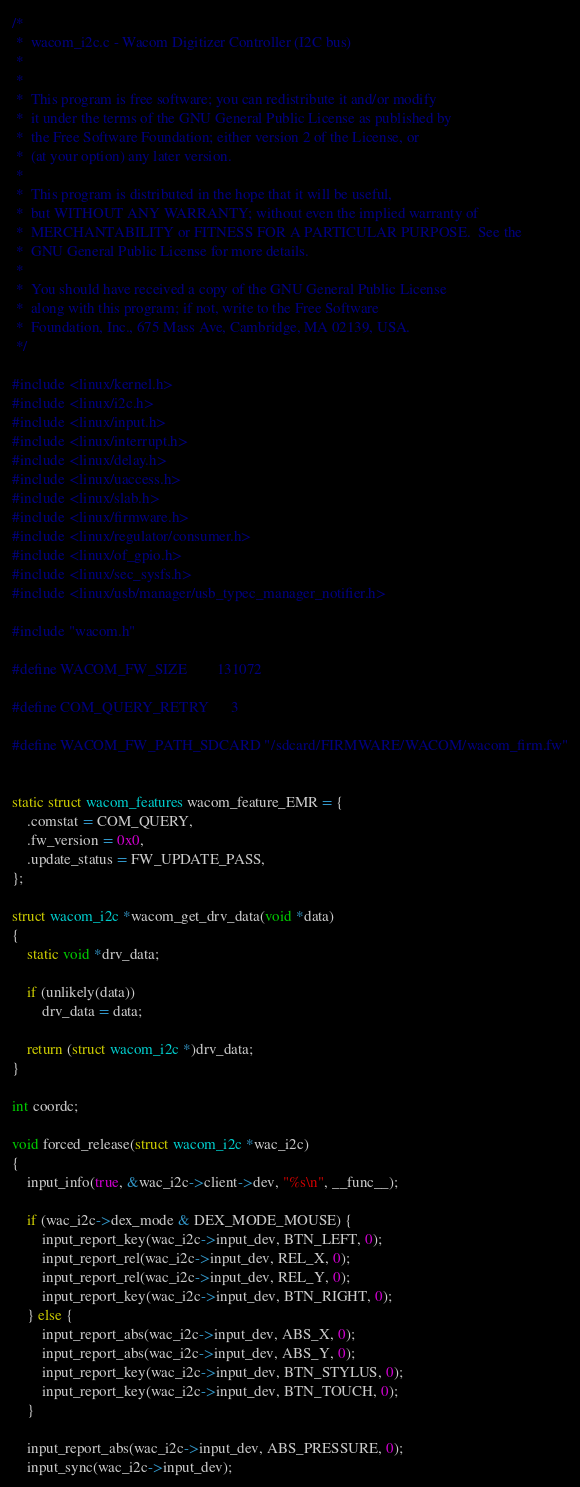<code> <loc_0><loc_0><loc_500><loc_500><_C_>/*
 *  wacom_i2c.c - Wacom Digitizer Controller (I2C bus)
 *
 *
 *  This program is free software; you can redistribute it and/or modify
 *  it under the terms of the GNU General Public License as published by
 *  the Free Software Foundation; either version 2 of the License, or
 *  (at your option) any later version.
 *
 *  This program is distributed in the hope that it will be useful,
 *  but WITHOUT ANY WARRANTY; without even the implied warranty of
 *  MERCHANTABILITY or FITNESS FOR A PARTICULAR PURPOSE.  See the
 *  GNU General Public License for more details.
 *
 *  You should have received a copy of the GNU General Public License
 *  along with this program; if not, write to the Free Software
 *  Foundation, Inc., 675 Mass Ave, Cambridge, MA 02139, USA.
 */

#include <linux/kernel.h>
#include <linux/i2c.h>
#include <linux/input.h>
#include <linux/interrupt.h>
#include <linux/delay.h>
#include <linux/uaccess.h>
#include <linux/slab.h>
#include <linux/firmware.h>
#include <linux/regulator/consumer.h>
#include <linux/of_gpio.h>
#include <linux/sec_sysfs.h>
#include <linux/usb/manager/usb_typec_manager_notifier.h>

#include "wacom.h"

#define WACOM_FW_SIZE		131072

#define COM_QUERY_RETRY		3

#define WACOM_FW_PATH_SDCARD	"/sdcard/FIRMWARE/WACOM/wacom_firm.fw"


static struct wacom_features wacom_feature_EMR = {
	.comstat = COM_QUERY,
	.fw_version = 0x0,
	.update_status = FW_UPDATE_PASS,
};

struct wacom_i2c *wacom_get_drv_data(void *data)
{
	static void *drv_data;

	if (unlikely(data))
		drv_data = data;

	return (struct wacom_i2c *)drv_data;
}

int coordc;

void forced_release(struct wacom_i2c *wac_i2c)
{
	input_info(true, &wac_i2c->client->dev, "%s\n", __func__);

	if (wac_i2c->dex_mode & DEX_MODE_MOUSE) {
		input_report_key(wac_i2c->input_dev, BTN_LEFT, 0);
		input_report_rel(wac_i2c->input_dev, REL_X, 0);
		input_report_rel(wac_i2c->input_dev, REL_Y, 0);
		input_report_key(wac_i2c->input_dev, BTN_RIGHT, 0);
	} else {
		input_report_abs(wac_i2c->input_dev, ABS_X, 0);
		input_report_abs(wac_i2c->input_dev, ABS_Y, 0);
		input_report_key(wac_i2c->input_dev, BTN_STYLUS, 0);
		input_report_key(wac_i2c->input_dev, BTN_TOUCH, 0);
	}

	input_report_abs(wac_i2c->input_dev, ABS_PRESSURE, 0);
	input_sync(wac_i2c->input_dev);
</code> 